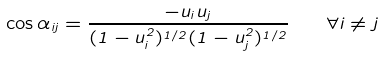Convert formula to latex. <formula><loc_0><loc_0><loc_500><loc_500>\cos { \alpha _ { i j } } = \frac { - u _ { i } u _ { j } } { ( 1 - u _ { i } ^ { 2 } ) ^ { 1 / 2 } ( 1 - u _ { j } ^ { 2 } ) ^ { 1 / 2 } } \quad \forall i \neq j</formula> 